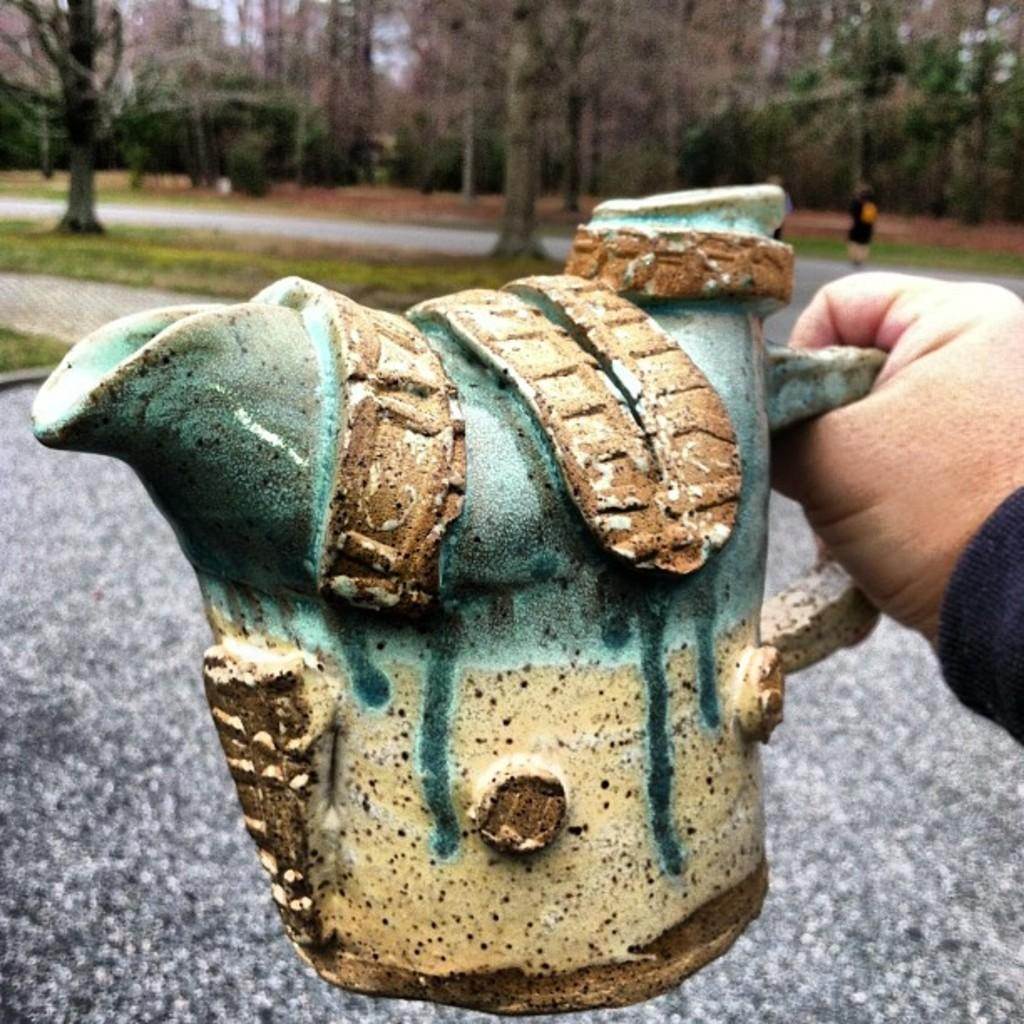What is the hand holding in the image? The hand is holding an object in the image, but the specific object is not mentioned in the facts. How many people are visible in the image? There are two persons standing on the road in the image. What can be seen in the background of the image? There are trees in the background of the image. What type of snow can be seen falling in the image? There is no mention of snow in the image, so it cannot be seen falling. What kind of teeth are visible in the image? There are no teeth visible in the image. 